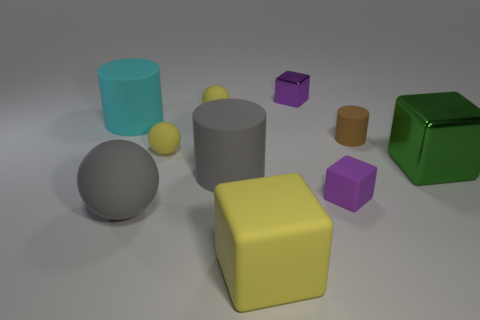Is the number of large yellow things that are on the left side of the big yellow matte object less than the number of small purple things that are right of the small purple metal thing?
Keep it short and to the point. Yes. Do the brown object and the purple block behind the small matte cube have the same size?
Your answer should be very brief. Yes. What number of green metal cubes are the same size as the brown object?
Offer a very short reply. 0. How many big things are spheres or yellow matte objects?
Ensure brevity in your answer.  2. Is there a brown matte cylinder?
Your answer should be very brief. Yes. Are there more small yellow rubber objects that are in front of the big cyan rubber thing than green blocks in front of the green block?
Give a very brief answer. Yes. There is a big matte cylinder to the left of the gray thing that is in front of the small purple matte object; what is its color?
Offer a very short reply. Cyan. Are there any matte blocks that have the same color as the tiny metallic block?
Ensure brevity in your answer.  Yes. There is a gray rubber object behind the sphere in front of the tiny yellow matte thing in front of the brown rubber cylinder; what is its size?
Make the answer very short. Large. What is the shape of the big green shiny object?
Offer a terse response. Cube. 